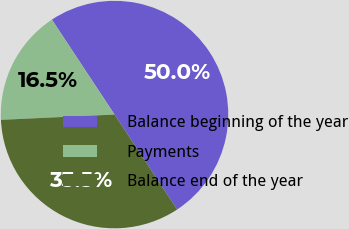Convert chart. <chart><loc_0><loc_0><loc_500><loc_500><pie_chart><fcel>Balance beginning of the year<fcel>Payments<fcel>Balance end of the year<nl><fcel>50.0%<fcel>16.46%<fcel>33.54%<nl></chart> 